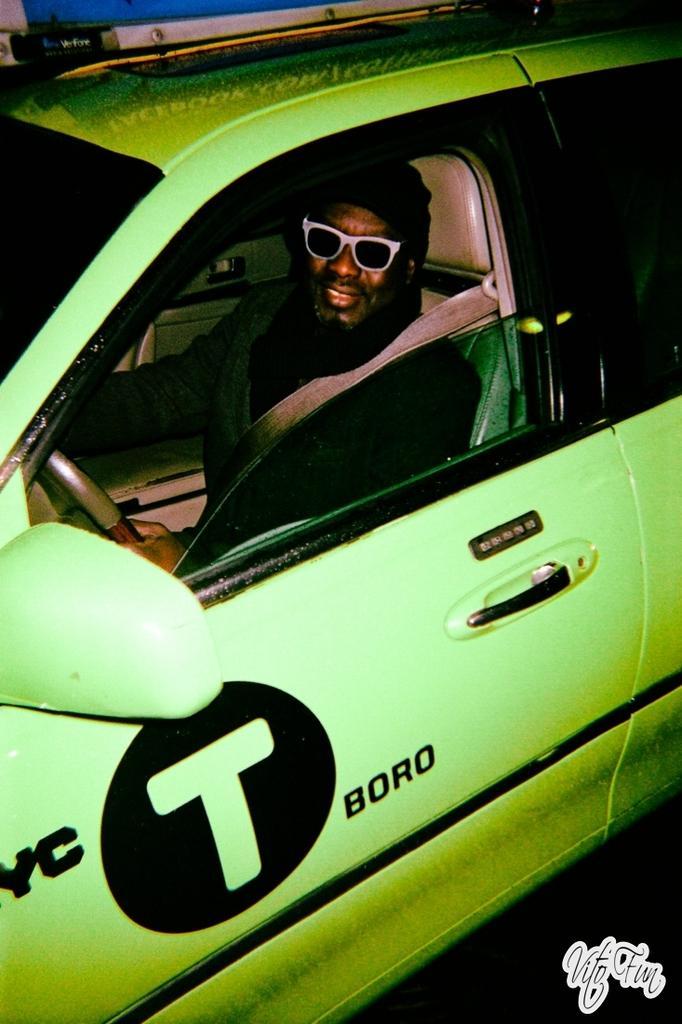In one or two sentences, can you explain what this image depicts? In the picture we can find a car a man in it. The man is wearing a seatbelt and holding a steering. The car is in green color with some design on it. 